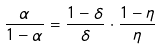<formula> <loc_0><loc_0><loc_500><loc_500>\frac { \alpha } { 1 - \alpha } = \frac { 1 - \delta } { \delta } \cdot \frac { 1 - \eta } { \eta }</formula> 